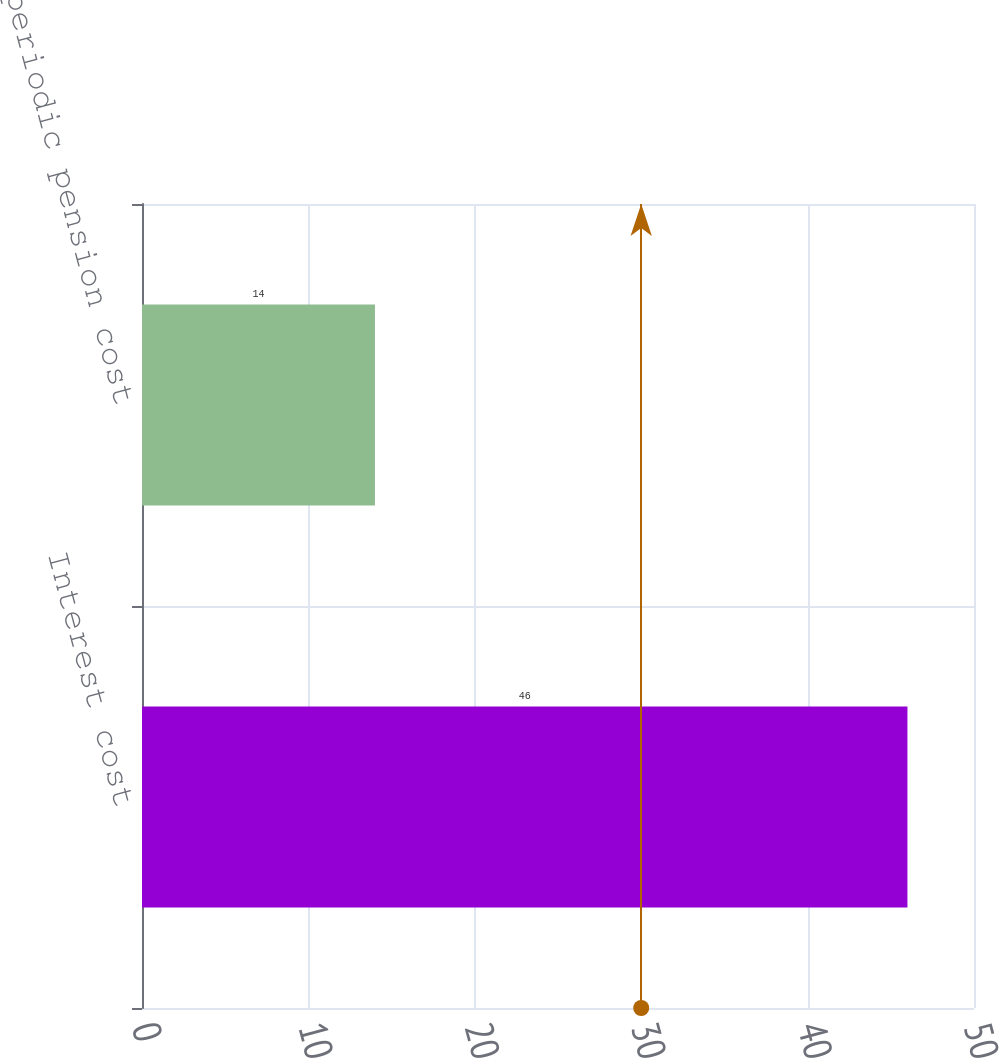Convert chart to OTSL. <chart><loc_0><loc_0><loc_500><loc_500><bar_chart><fcel>Interest cost<fcel>Net periodic pension cost<nl><fcel>46<fcel>14<nl></chart> 